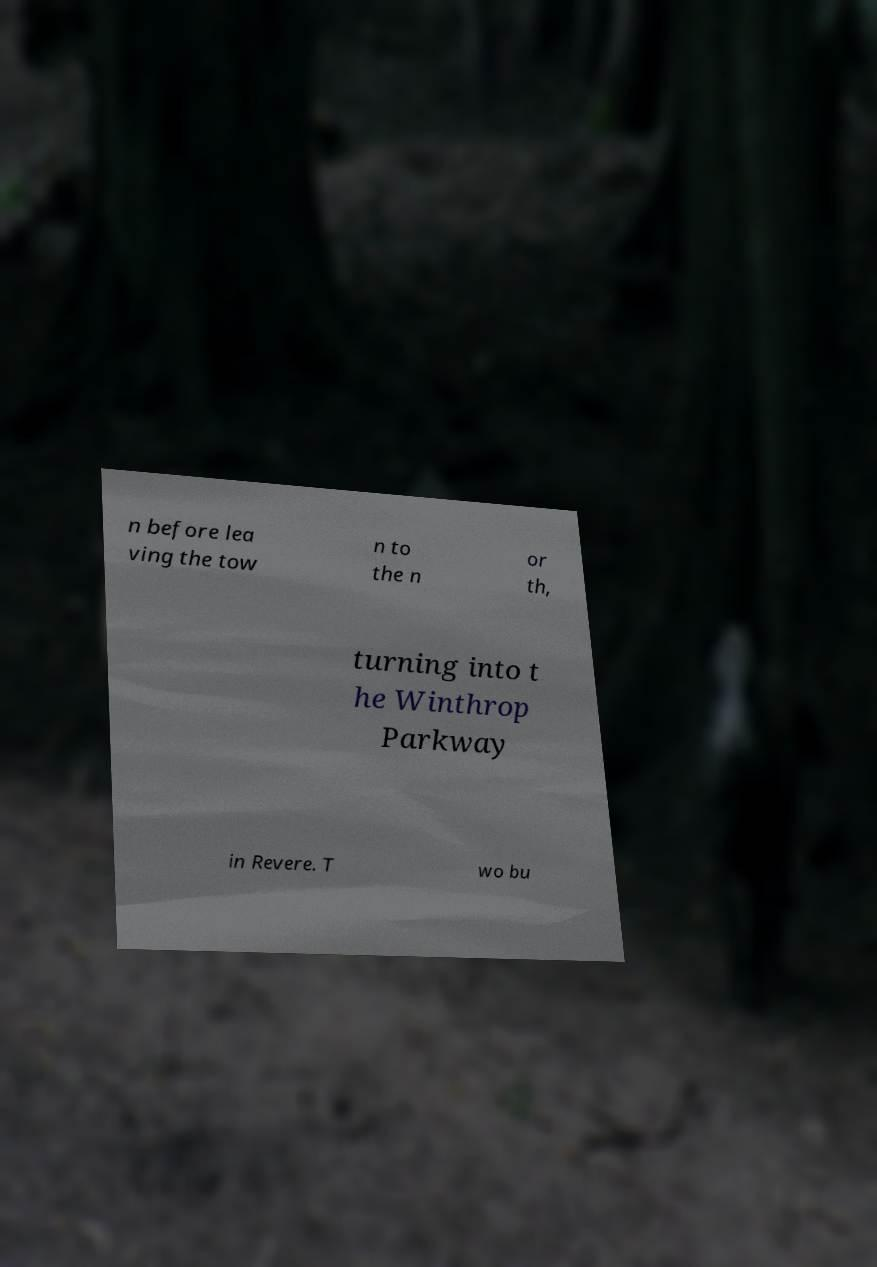Could you extract and type out the text from this image? n before lea ving the tow n to the n or th, turning into t he Winthrop Parkway in Revere. T wo bu 